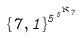<formula> <loc_0><loc_0><loc_500><loc_500>\{ 7 , 1 \} ^ { 5 ^ { 5 ^ { \aleph _ { 7 } } } }</formula> 